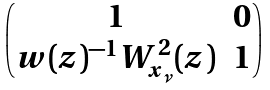<formula> <loc_0><loc_0><loc_500><loc_500>\begin{pmatrix} 1 & 0 \\ w ( z ) ^ { - 1 } W _ { x _ { \nu } } ^ { 2 } ( z ) & 1 \end{pmatrix}</formula> 